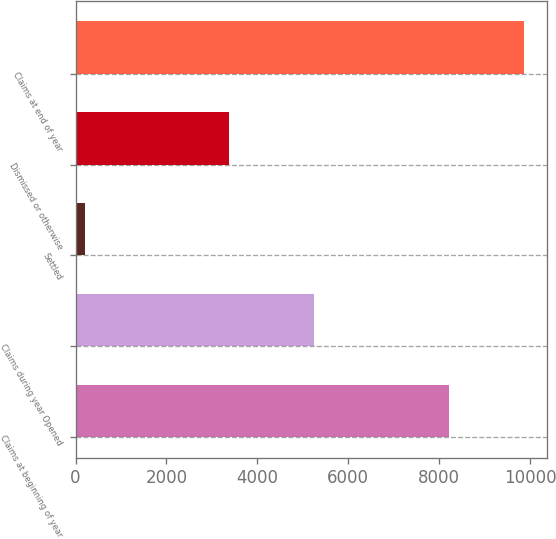<chart> <loc_0><loc_0><loc_500><loc_500><bar_chart><fcel>Claims at beginning of year<fcel>Claims during year Opened<fcel>Settled<fcel>Dismissed or otherwise<fcel>Claims at end of year<nl><fcel>8216<fcel>5253<fcel>219<fcel>3377<fcel>9873<nl></chart> 